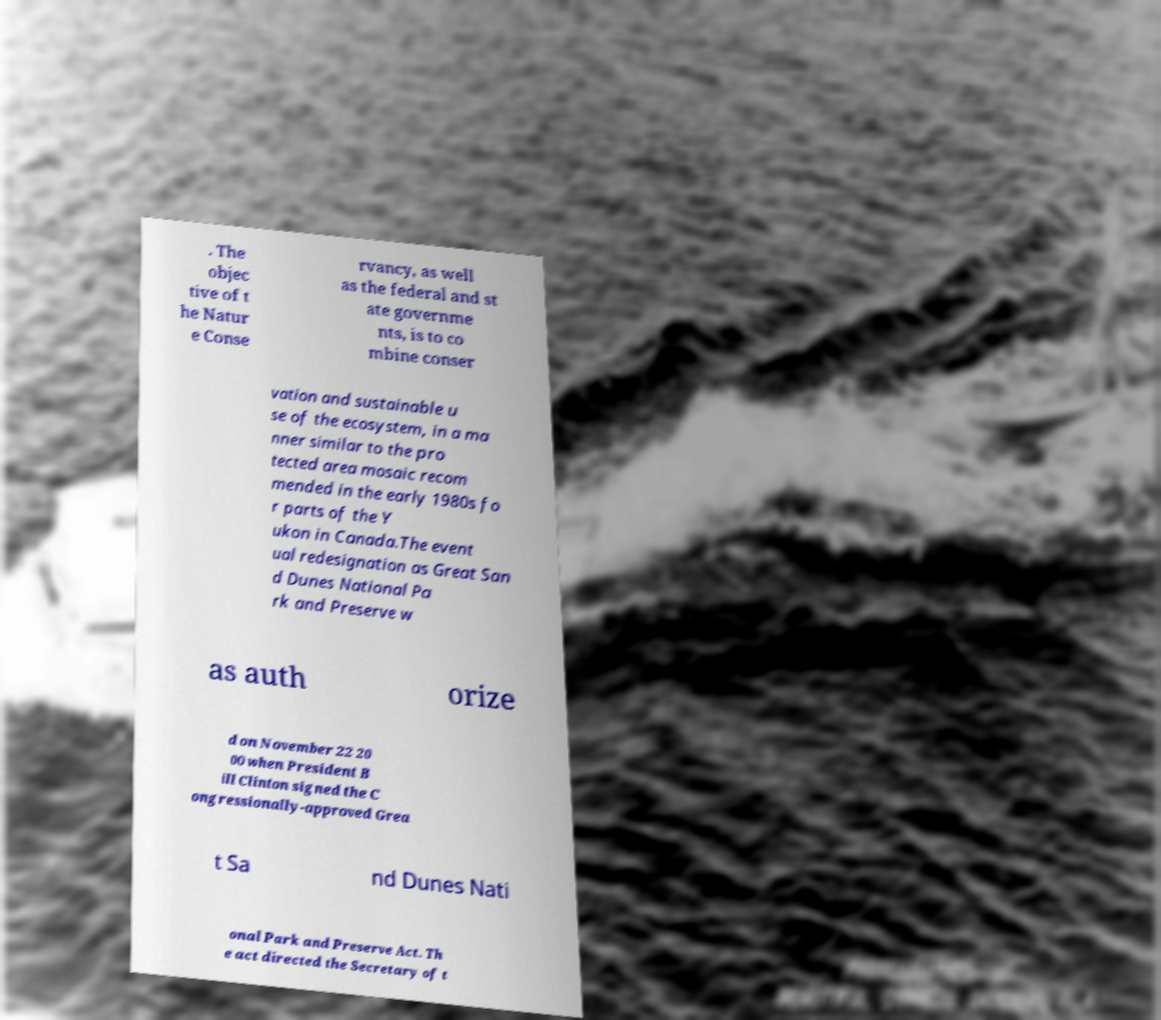Please identify and transcribe the text found in this image. . The objec tive of t he Natur e Conse rvancy, as well as the federal and st ate governme nts, is to co mbine conser vation and sustainable u se of the ecosystem, in a ma nner similar to the pro tected area mosaic recom mended in the early 1980s fo r parts of the Y ukon in Canada.The event ual redesignation as Great San d Dunes National Pa rk and Preserve w as auth orize d on November 22 20 00 when President B ill Clinton signed the C ongressionally-approved Grea t Sa nd Dunes Nati onal Park and Preserve Act. Th e act directed the Secretary of t 